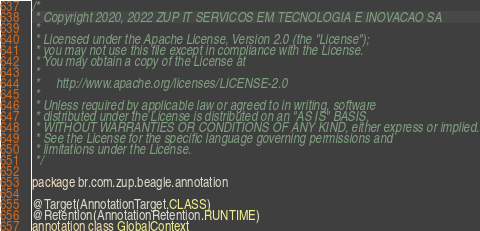Convert code to text. <code><loc_0><loc_0><loc_500><loc_500><_Kotlin_>/*
 * Copyright 2020, 2022 ZUP IT SERVICOS EM TECNOLOGIA E INOVACAO SA
 *
 * Licensed under the Apache License, Version 2.0 (the "License");
 * you may not use this file except in compliance with the License.
 * You may obtain a copy of the License at
 *
 *     http://www.apache.org/licenses/LICENSE-2.0
 *
 * Unless required by applicable law or agreed to in writing, software
 * distributed under the License is distributed on an "AS IS" BASIS,
 * WITHOUT WARRANTIES OR CONDITIONS OF ANY KIND, either express or implied.
 * See the License for the specific language governing permissions and
 * limitations under the License.
 */

package br.com.zup.beagle.annotation

@Target(AnnotationTarget.CLASS)
@Retention(AnnotationRetention.RUNTIME)
annotation class GlobalContext</code> 